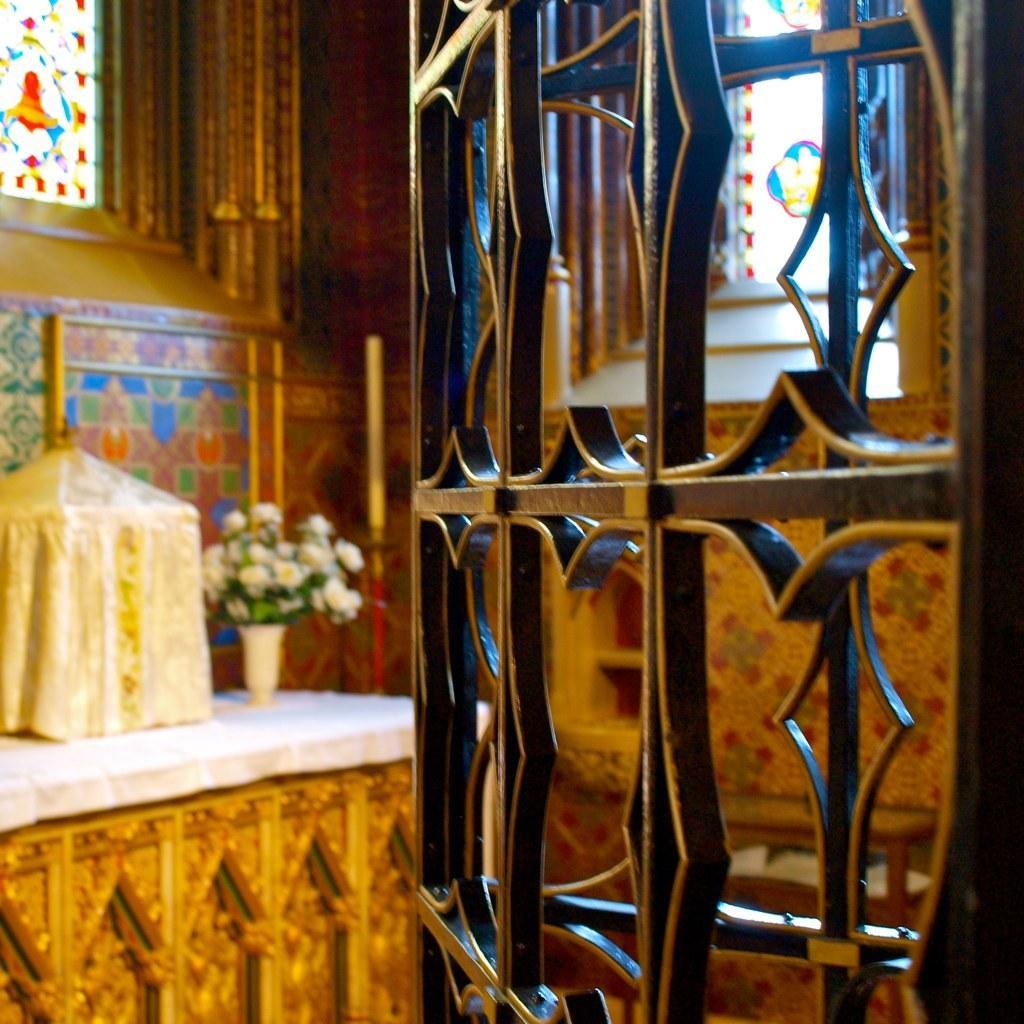Can you describe this image briefly? In this image there is an iron frame, in the background there is a table, on that table there is a flower vase and a box and there is a wall for that wall there are glass windows. 